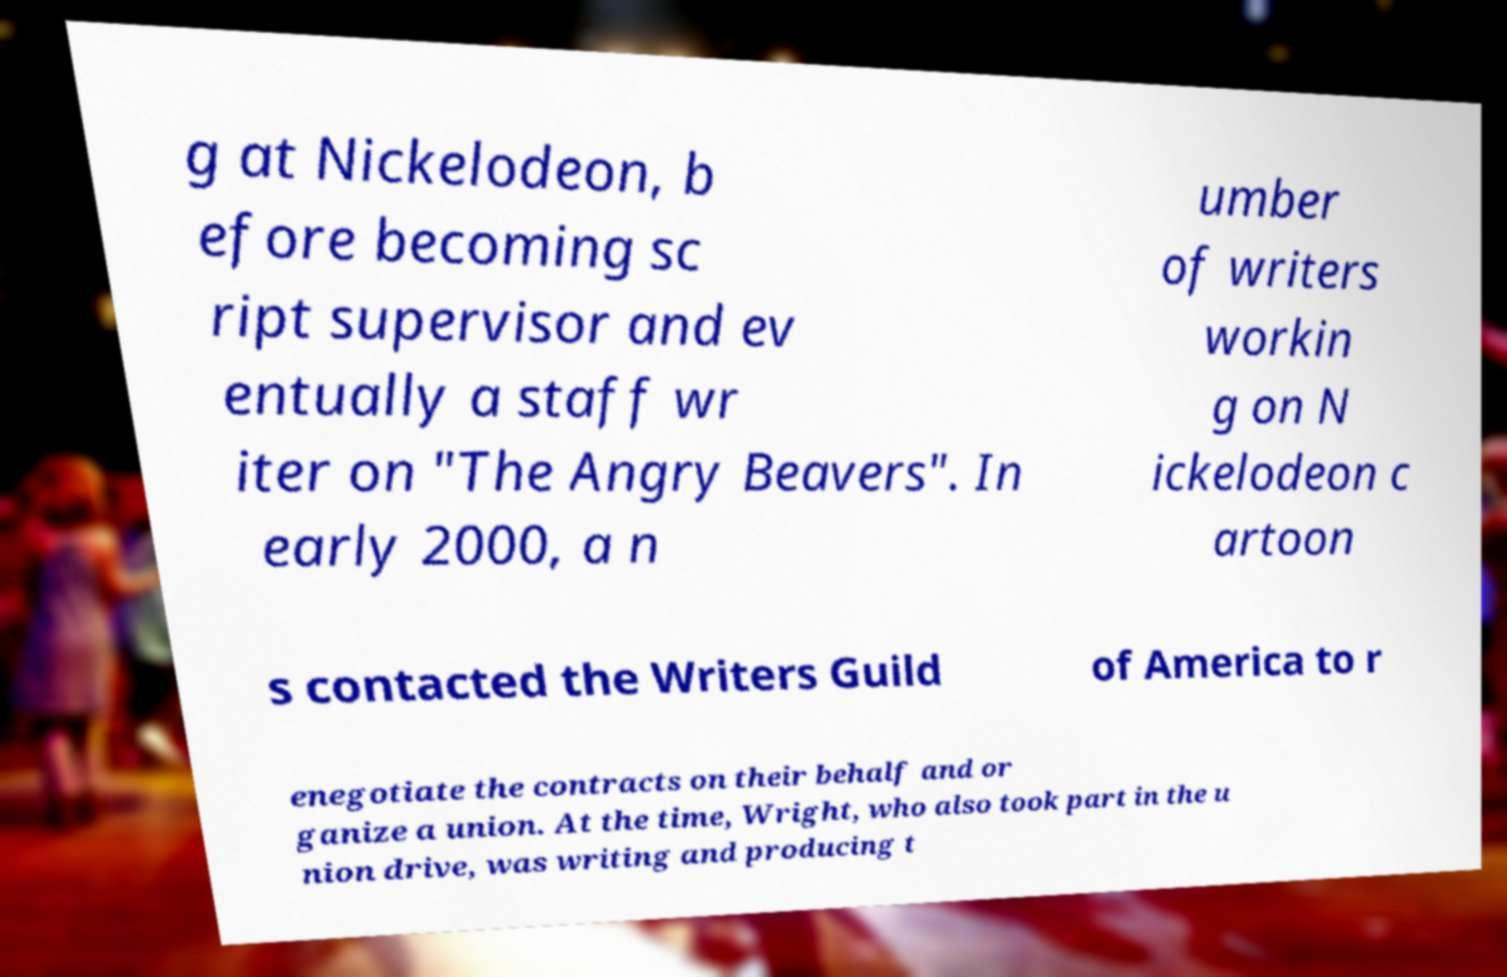For documentation purposes, I need the text within this image transcribed. Could you provide that? g at Nickelodeon, b efore becoming sc ript supervisor and ev entually a staff wr iter on "The Angry Beavers". In early 2000, a n umber of writers workin g on N ickelodeon c artoon s contacted the Writers Guild of America to r enegotiate the contracts on their behalf and or ganize a union. At the time, Wright, who also took part in the u nion drive, was writing and producing t 